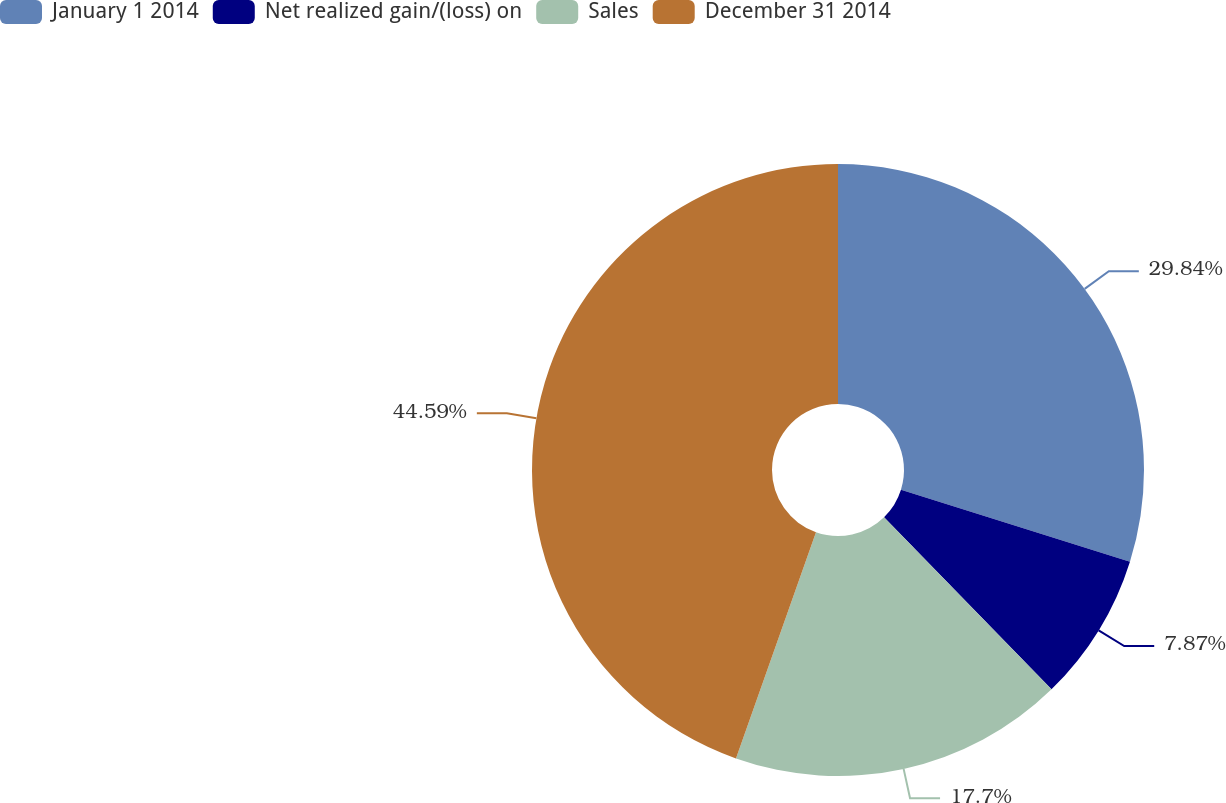Convert chart. <chart><loc_0><loc_0><loc_500><loc_500><pie_chart><fcel>January 1 2014<fcel>Net realized gain/(loss) on<fcel>Sales<fcel>December 31 2014<nl><fcel>29.84%<fcel>7.87%<fcel>17.7%<fcel>44.59%<nl></chart> 